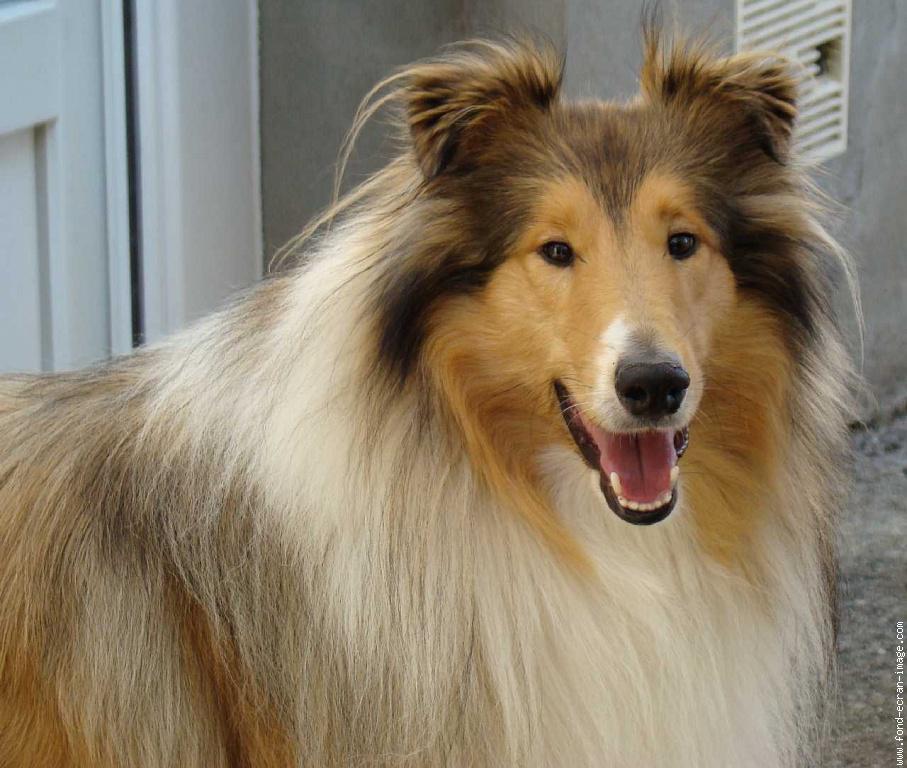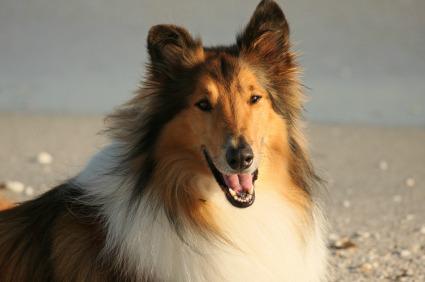The first image is the image on the left, the second image is the image on the right. Examine the images to the left and right. Is the description "The left image features a collie on a mottled, non-white portrait background." accurate? Answer yes or no. No. 